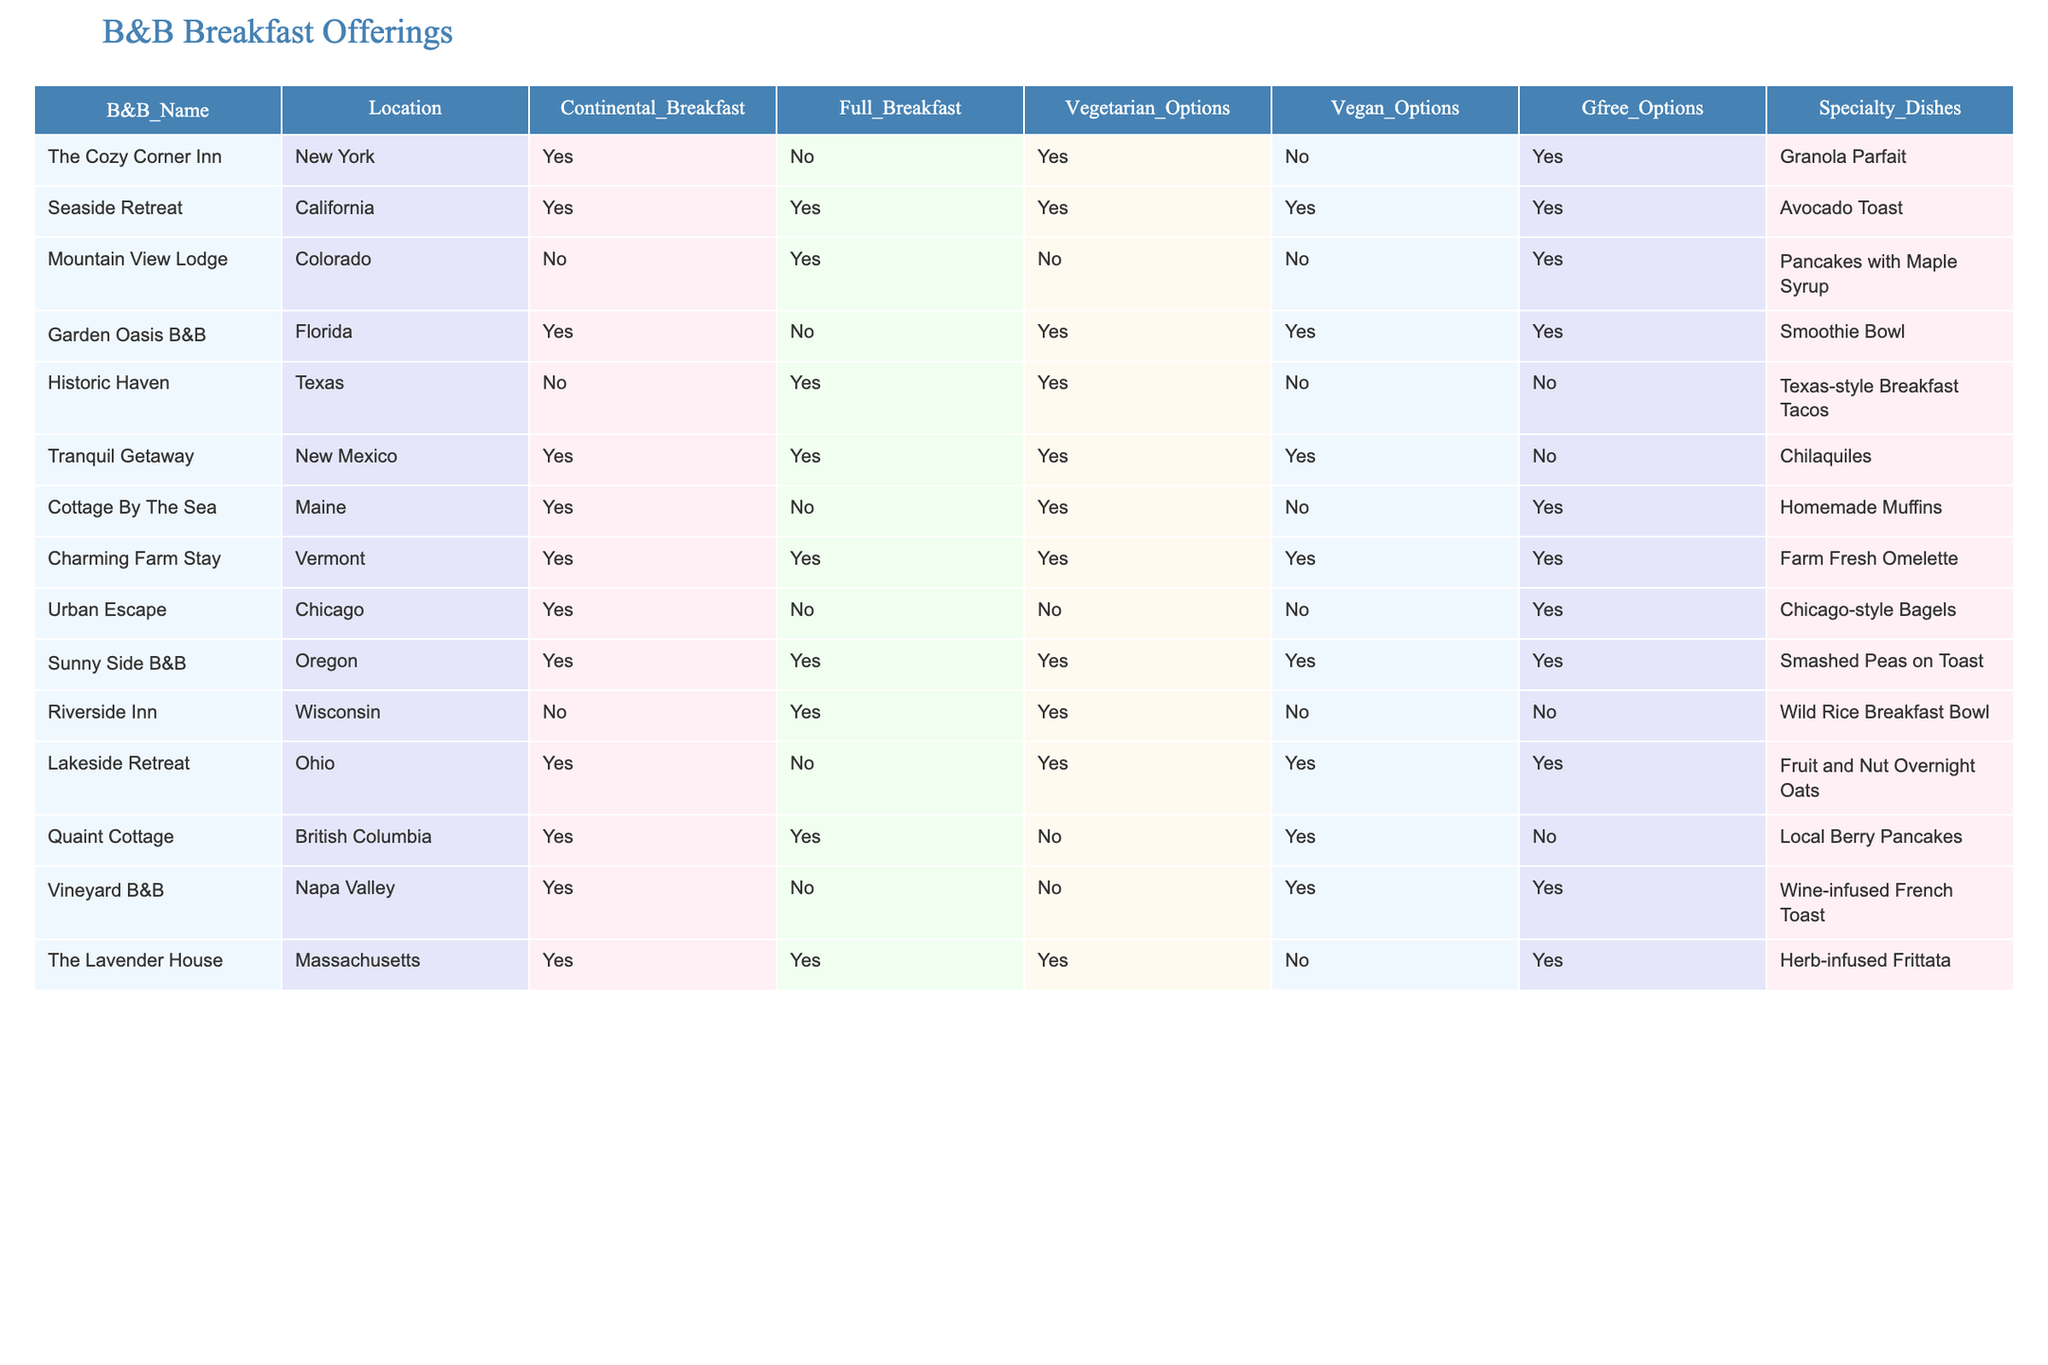What is the total number of B&Bs offering a full breakfast? The table lists each B&B with a "Full Breakfast" column. Counting the "Yes" entries in this column gives us a total of 7 B&Bs that offer a full breakfast.
Answer: 7 Which B&Bs provide vegan options? The "Vegan Options" column shows which B&Bs offer vegan breakfast choices. Checking this column, we find that there are 5 B&Bs with "Yes" in this category: Seaside Retreat, Garden Oasis B&B, Tranquil Getaway, Sunny Side B&B, and Vineyard B&B.
Answer: Seaside Retreat, Garden Oasis B&B, Tranquil Getaway, Sunny Side B&B, Vineyard B&B Does the Riverside Inn offer a continental breakfast? Looking at the "Continental Breakfast" column for Riverside Inn, the entry indicates "No," meaning it does not offer a continental breakfast.
Answer: No How many B&Bs offer gluten-free options? The "Gfree Options" column must be referenced for this inquiry. Counting the "Yes" entries results in a total of 6 B&Bs that provide gluten-free options.
Answer: 6 Which B&B has the specialty dish of "Homemade Muffins"? By scanning the "Specialty Dishes" column, we can see that the B&B named "Cottage By The Sea" lists "Homemade Muffins" as its specialty dish.
Answer: Cottage By The Sea Which location has the most dietary options overall? We can evaluate each B&B by counting the number of dietary options (Vegetarian, Vegan, Gfree) available. Adding the respective counts shows that Charming Farm Stay offers the highest variety, having 5 options (Full Breakfast, Vegetarian, Vegan, Gfree, Specialty Dishes). The others have fewer combined options.
Answer: Charming Farm Stay How many B&Bs offer both vegetarian and vegan options? The relevant columns to consider are "Vegetarian Options" and "Vegan Options." By counting the entries where both are "Yes," we find 4 B&Bs: Seaside Retreat, Garden Oasis B&B, Tranquil Getaway, and Sunny Side B&B.
Answer: 4 Is "Texas-style Breakfast Tacos" a specialty dish at any B&B? By reviewing the "Specialty Dishes" column, we see that "Texas-style Breakfast Tacos" is associated with Historic Haven, confirming it as a specialty dish at that B&B.
Answer: Yes How many B&Bs offer only a continental breakfast and no other options? Looking at the table, we find that Urban Escape is the sole B&B that offers only a continental breakfast and lacks a full breakfast, vegetarian, vegan, and gluten-free options.
Answer: 1 